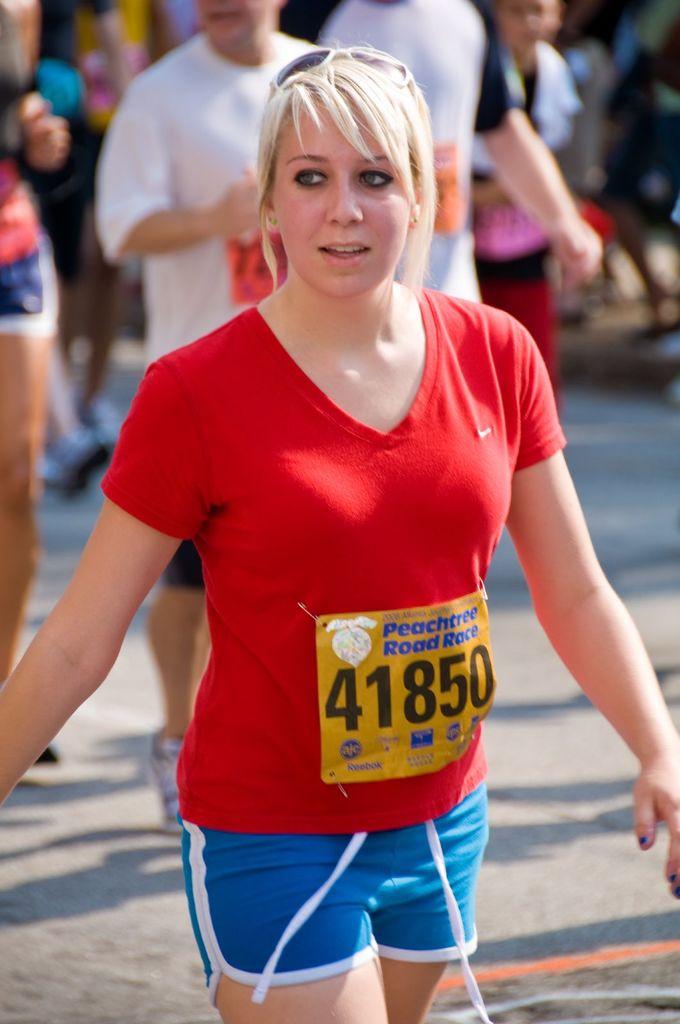What is the name of the race she s running?
Your answer should be compact. Peachtree road race. What is her number?
Offer a very short reply. 41850. 